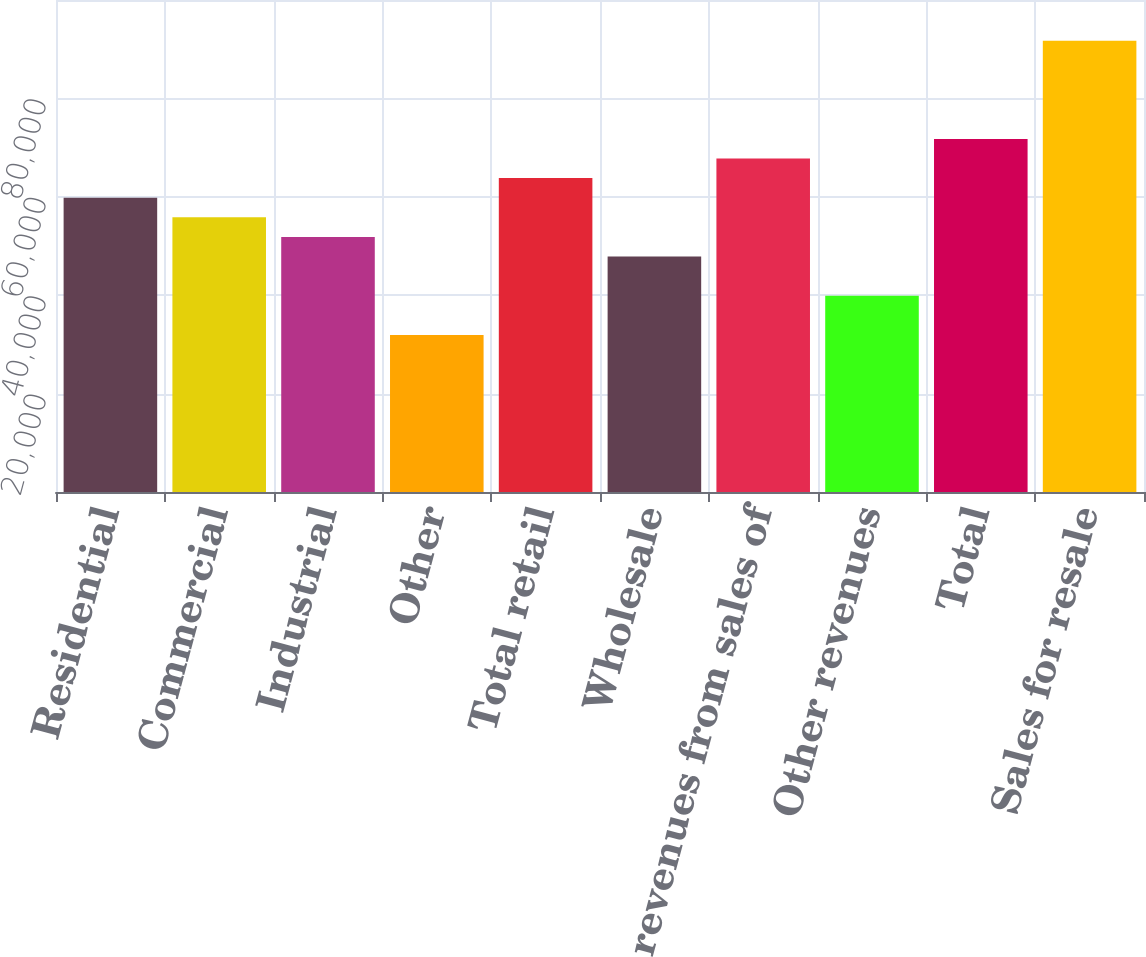<chart> <loc_0><loc_0><loc_500><loc_500><bar_chart><fcel>Residential<fcel>Commercial<fcel>Industrial<fcel>Other<fcel>Total retail<fcel>Wholesale<fcel>Total revenues from sales of<fcel>Other revenues<fcel>Total<fcel>Sales for resale<nl><fcel>59810.6<fcel>55823.4<fcel>51836.3<fcel>31900.8<fcel>63797.7<fcel>47849.2<fcel>67784.8<fcel>39875<fcel>71771.9<fcel>91707.4<nl></chart> 